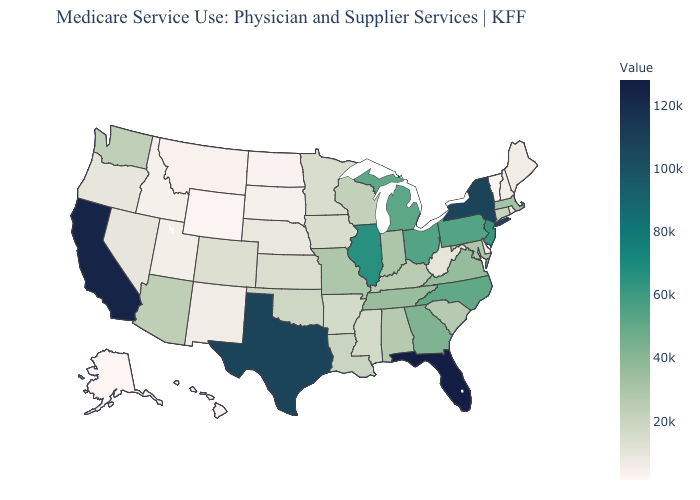Which states have the lowest value in the USA?
Answer briefly. Alaska. Is the legend a continuous bar?
Concise answer only. Yes. Which states hav the highest value in the MidWest?
Give a very brief answer. Illinois. Does the map have missing data?
Concise answer only. No. Which states have the lowest value in the Northeast?
Answer briefly. Vermont. Among the states that border Florida , which have the highest value?
Quick response, please. Georgia. 